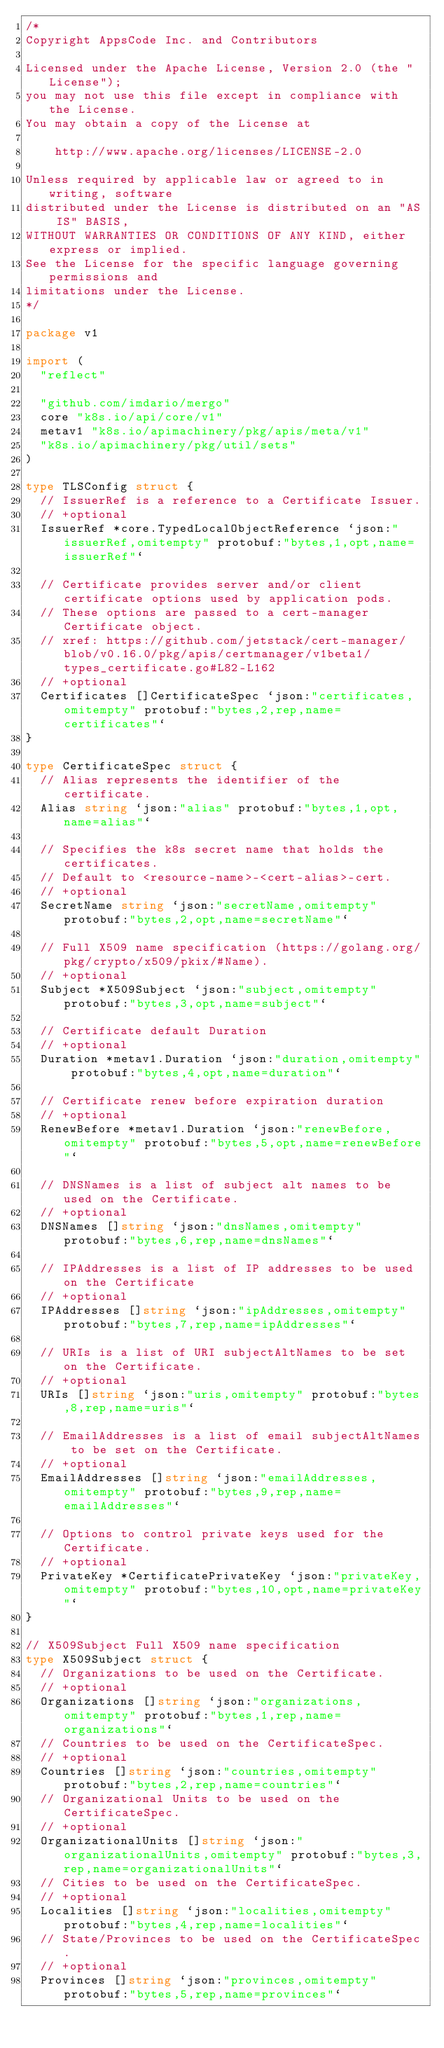Convert code to text. <code><loc_0><loc_0><loc_500><loc_500><_Go_>/*
Copyright AppsCode Inc. and Contributors

Licensed under the Apache License, Version 2.0 (the "License");
you may not use this file except in compliance with the License.
You may obtain a copy of the License at

    http://www.apache.org/licenses/LICENSE-2.0

Unless required by applicable law or agreed to in writing, software
distributed under the License is distributed on an "AS IS" BASIS,
WITHOUT WARRANTIES OR CONDITIONS OF ANY KIND, either express or implied.
See the License for the specific language governing permissions and
limitations under the License.
*/

package v1

import (
	"reflect"

	"github.com/imdario/mergo"
	core "k8s.io/api/core/v1"
	metav1 "k8s.io/apimachinery/pkg/apis/meta/v1"
	"k8s.io/apimachinery/pkg/util/sets"
)

type TLSConfig struct {
	// IssuerRef is a reference to a Certificate Issuer.
	// +optional
	IssuerRef *core.TypedLocalObjectReference `json:"issuerRef,omitempty" protobuf:"bytes,1,opt,name=issuerRef"`

	// Certificate provides server and/or client certificate options used by application pods.
	// These options are passed to a cert-manager Certificate object.
	// xref: https://github.com/jetstack/cert-manager/blob/v0.16.0/pkg/apis/certmanager/v1beta1/types_certificate.go#L82-L162
	// +optional
	Certificates []CertificateSpec `json:"certificates,omitempty" protobuf:"bytes,2,rep,name=certificates"`
}

type CertificateSpec struct {
	// Alias represents the identifier of the certificate.
	Alias string `json:"alias" protobuf:"bytes,1,opt,name=alias"`

	// Specifies the k8s secret name that holds the certificates.
	// Default to <resource-name>-<cert-alias>-cert.
	// +optional
	SecretName string `json:"secretName,omitempty" protobuf:"bytes,2,opt,name=secretName"`

	// Full X509 name specification (https://golang.org/pkg/crypto/x509/pkix/#Name).
	// +optional
	Subject *X509Subject `json:"subject,omitempty" protobuf:"bytes,3,opt,name=subject"`

	// Certificate default Duration
	// +optional
	Duration *metav1.Duration `json:"duration,omitempty" protobuf:"bytes,4,opt,name=duration"`

	// Certificate renew before expiration duration
	// +optional
	RenewBefore *metav1.Duration `json:"renewBefore,omitempty" protobuf:"bytes,5,opt,name=renewBefore"`

	// DNSNames is a list of subject alt names to be used on the Certificate.
	// +optional
	DNSNames []string `json:"dnsNames,omitempty" protobuf:"bytes,6,rep,name=dnsNames"`

	// IPAddresses is a list of IP addresses to be used on the Certificate
	// +optional
	IPAddresses []string `json:"ipAddresses,omitempty" protobuf:"bytes,7,rep,name=ipAddresses"`

	// URIs is a list of URI subjectAltNames to be set on the Certificate.
	// +optional
	URIs []string `json:"uris,omitempty" protobuf:"bytes,8,rep,name=uris"`

	// EmailAddresses is a list of email subjectAltNames to be set on the Certificate.
	// +optional
	EmailAddresses []string `json:"emailAddresses,omitempty" protobuf:"bytes,9,rep,name=emailAddresses"`

	// Options to control private keys used for the Certificate.
	// +optional
	PrivateKey *CertificatePrivateKey `json:"privateKey,omitempty" protobuf:"bytes,10,opt,name=privateKey"`
}

// X509Subject Full X509 name specification
type X509Subject struct {
	// Organizations to be used on the Certificate.
	// +optional
	Organizations []string `json:"organizations,omitempty" protobuf:"bytes,1,rep,name=organizations"`
	// Countries to be used on the CertificateSpec.
	// +optional
	Countries []string `json:"countries,omitempty" protobuf:"bytes,2,rep,name=countries"`
	// Organizational Units to be used on the CertificateSpec.
	// +optional
	OrganizationalUnits []string `json:"organizationalUnits,omitempty" protobuf:"bytes,3,rep,name=organizationalUnits"`
	// Cities to be used on the CertificateSpec.
	// +optional
	Localities []string `json:"localities,omitempty" protobuf:"bytes,4,rep,name=localities"`
	// State/Provinces to be used on the CertificateSpec.
	// +optional
	Provinces []string `json:"provinces,omitempty" protobuf:"bytes,5,rep,name=provinces"`</code> 